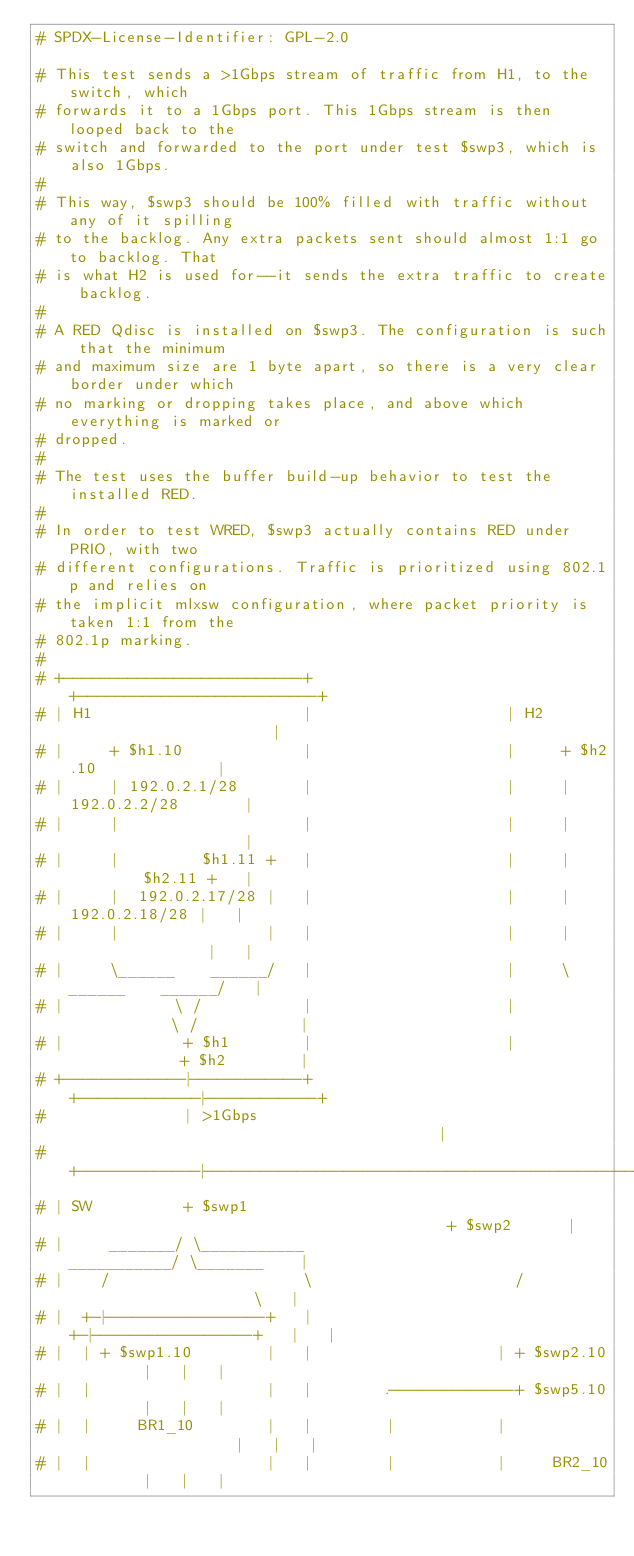<code> <loc_0><loc_0><loc_500><loc_500><_Bash_># SPDX-License-Identifier: GPL-2.0

# This test sends a >1Gbps stream of traffic from H1, to the switch, which
# forwards it to a 1Gbps port. This 1Gbps stream is then looped back to the
# switch and forwarded to the port under test $swp3, which is also 1Gbps.
#
# This way, $swp3 should be 100% filled with traffic without any of it spilling
# to the backlog. Any extra packets sent should almost 1:1 go to backlog. That
# is what H2 is used for--it sends the extra traffic to create backlog.
#
# A RED Qdisc is installed on $swp3. The configuration is such that the minimum
# and maximum size are 1 byte apart, so there is a very clear border under which
# no marking or dropping takes place, and above which everything is marked or
# dropped.
#
# The test uses the buffer build-up behavior to test the installed RED.
#
# In order to test WRED, $swp3 actually contains RED under PRIO, with two
# different configurations. Traffic is prioritized using 802.1p and relies on
# the implicit mlxsw configuration, where packet priority is taken 1:1 from the
# 802.1p marking.
#
# +--------------------------+                     +--------------------------+
# | H1                       |                     | H2                       |
# |     + $h1.10             |                     |     + $h2.10             |
# |     | 192.0.2.1/28       |                     |     | 192.0.2.2/28       |
# |     |                    |                     |     |                    |
# |     |         $h1.11 +   |                     |     |         $h2.11 +   |
# |     |  192.0.2.17/28 |   |                     |     |  192.0.2.18/28 |   |
# |     |                |   |                     |     |                |   |
# |     \______    ______/   |                     |     \______    ______/   |
# |            \ /           |                     |            \ /           |
# |             + $h1        |                     |             + $h2        |
# +-------------|------------+                     +-------------|------------+
#               | >1Gbps                                         |
# +-------------|------------------------------------------------|------------+
# | SW          + $swp1                                          + $swp2      |
# |     _______/ \___________                        ___________/ \_______    |
# |    /                     \                      /                     \   |
# |  +-|-----------------+   |                    +-|-----------------+   |   |
# |  | + $swp1.10        |   |                    | + $swp2.10        |   |   |
# |  |                   |   |        .-------------+ $swp5.10        |   |   |
# |  |     BR1_10        |   |        |           |                   |   |   |
# |  |                   |   |        |           |     BR2_10        |   |   |</code> 